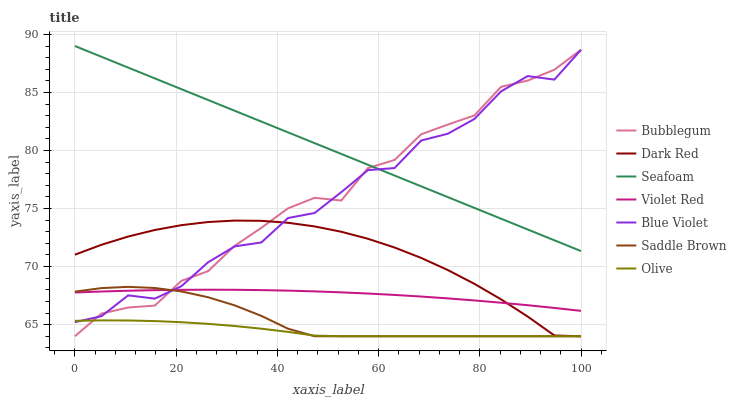Does Olive have the minimum area under the curve?
Answer yes or no. Yes. Does Seafoam have the maximum area under the curve?
Answer yes or no. Yes. Does Dark Red have the minimum area under the curve?
Answer yes or no. No. Does Dark Red have the maximum area under the curve?
Answer yes or no. No. Is Seafoam the smoothest?
Answer yes or no. Yes. Is Blue Violet the roughest?
Answer yes or no. Yes. Is Dark Red the smoothest?
Answer yes or no. No. Is Dark Red the roughest?
Answer yes or no. No. Does Dark Red have the lowest value?
Answer yes or no. Yes. Does Seafoam have the lowest value?
Answer yes or no. No. Does Seafoam have the highest value?
Answer yes or no. Yes. Does Dark Red have the highest value?
Answer yes or no. No. Is Dark Red less than Seafoam?
Answer yes or no. Yes. Is Seafoam greater than Saddle Brown?
Answer yes or no. Yes. Does Blue Violet intersect Seafoam?
Answer yes or no. Yes. Is Blue Violet less than Seafoam?
Answer yes or no. No. Is Blue Violet greater than Seafoam?
Answer yes or no. No. Does Dark Red intersect Seafoam?
Answer yes or no. No. 